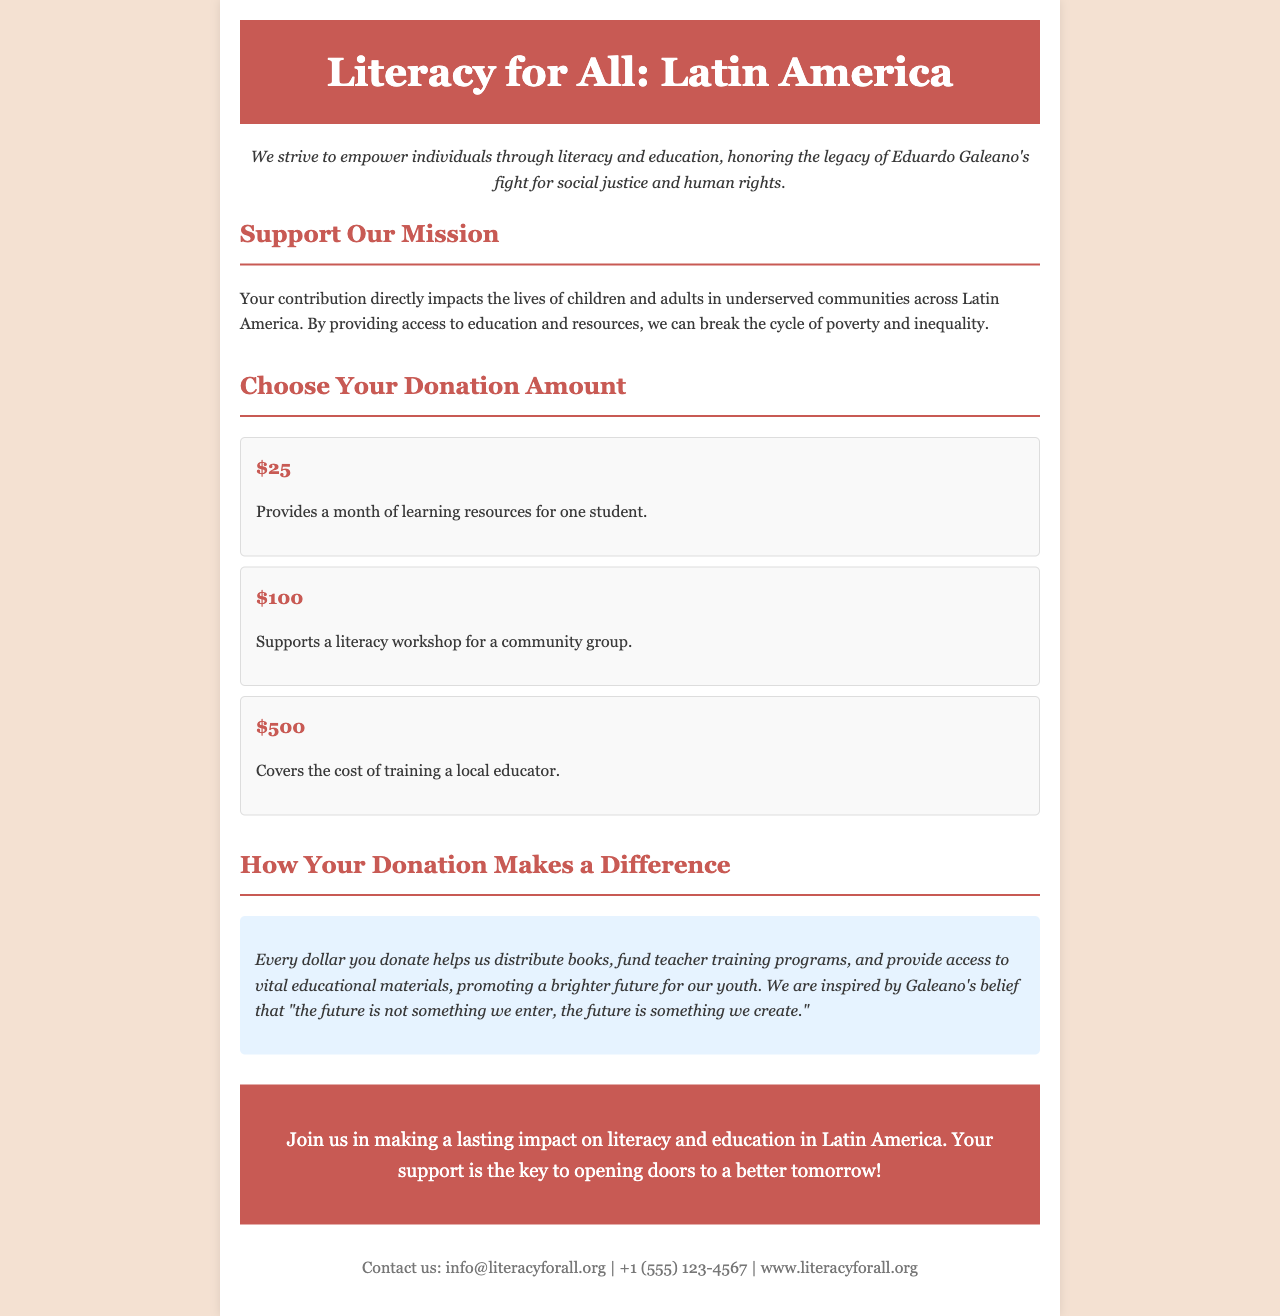what is the title of the document? The title of the document is presented prominently at the top, stating the purpose of the organization.
Answer: Literacy for All: Latin America what is the email contact provided? The document includes a specific email address for inquiries, found in the footer section.
Answer: info@literacyforall.org how much does it cost to support a literacy workshop? The document lists specific donation amounts and their impacts, including this particular support.
Answer: $100 what impact does a $500 donation cover? The document outlines the benefits associated with each donation option, stating what a $500 donation provides.
Answer: Covers the cost of training a local educator what is the mission statement's focus? The mission statement emphasizes the organization's commitment to empowerment through education, reflecting social justice ideals.
Answer: Empower individuals through literacy and education how many donation options are presented? The document lists different amounts available for donation, which indicates the number of distinct choices.
Answer: Three what is the percentage of children and adults affected? This type of information is implied in the document through descriptions of the communities served, though not explicitly stated.
Answer: Not provided what quote is attributed to Eduardo Galeano in the document? The document includes a quote by Galeano that captures the spirit of the organization's mission.
Answer: The future is not something we enter, the future is something we create what visual theme does the document employ? The document has specific styling elements geared toward a professional and inspiring representation, which reflects its purpose.
Answer: Professional and inspiring 